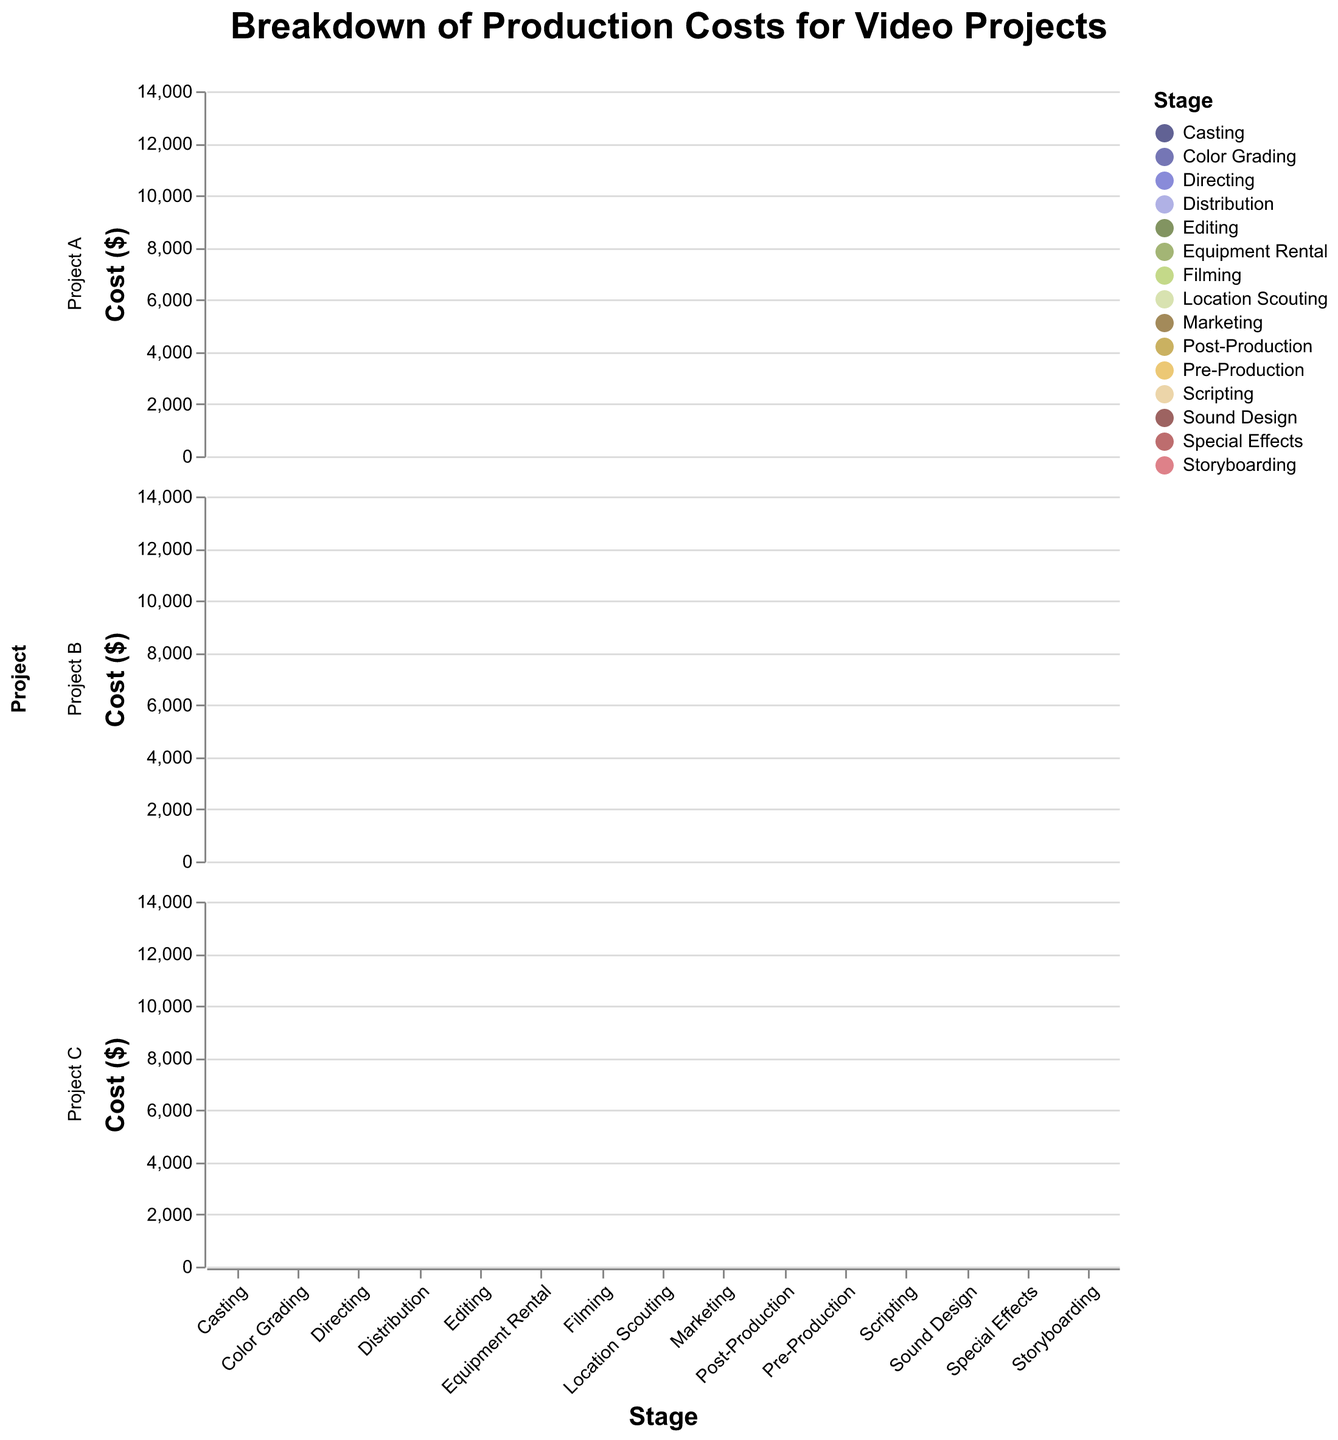What's the project with the highest total production cost? To find the project with the highest total production cost, add up all the stage costs for each project and compare the totals.
Answer: Project B Which stage incurs the highest cost for Project A? Look at the area chart for Project A and identify the stage with the highest peak.
Answer: Filming What is the combined cost of Casting and Directing for Project B? Add the costs of Casting ($2000) and Directing ($3000) for Project B.
Answer: $5000 Compare the costs of Editing across all projects. Which project spends the most on Editing? Look at the Editing stage for each project, compare the heights of the areas, and identify which project has the highest value.
Answer: Project B What's the total cost of pre-production activities (Pre-Production, Scripting, Storyboarding, Casting, Location Scouting) for Project C? Sum the costs for these stages in Project C: Pre-Production ($6000), Scripting ($3200), Storyboarding ($2100), Casting ($1700), Location Scouting ($1200). Add these values.
Answer: $14200 How does the cost of Equipment Rental in Project A compare to Project C? Look at the Equipment Rental stages for both projects and compare their values.
Answer: Project A has a cost of $3000 and Project C has a cost of $3500, so Project C is higher Which project allocates the least budget for Special Effects? Compare the heights of the Special Effects areas for each project and identify the smallest one.
Answer: Project A What's the average cost of Marketing across all projects? Add the Marketing costs for Project A ($3000), Project B ($4000), and Project C ($3500) and divide by the number of projects (3).
Answer: $3500 During which stage do all projects combined spend the most money? Identify the stage with the highest combined area heights across all projects.
Answer: Filming Which project has the smallest cost difference between Pre-Production and Post-Production? Calculate the difference between Pre-Production and Post-Production for each project and identify the smallest difference.
Answer: Project C 